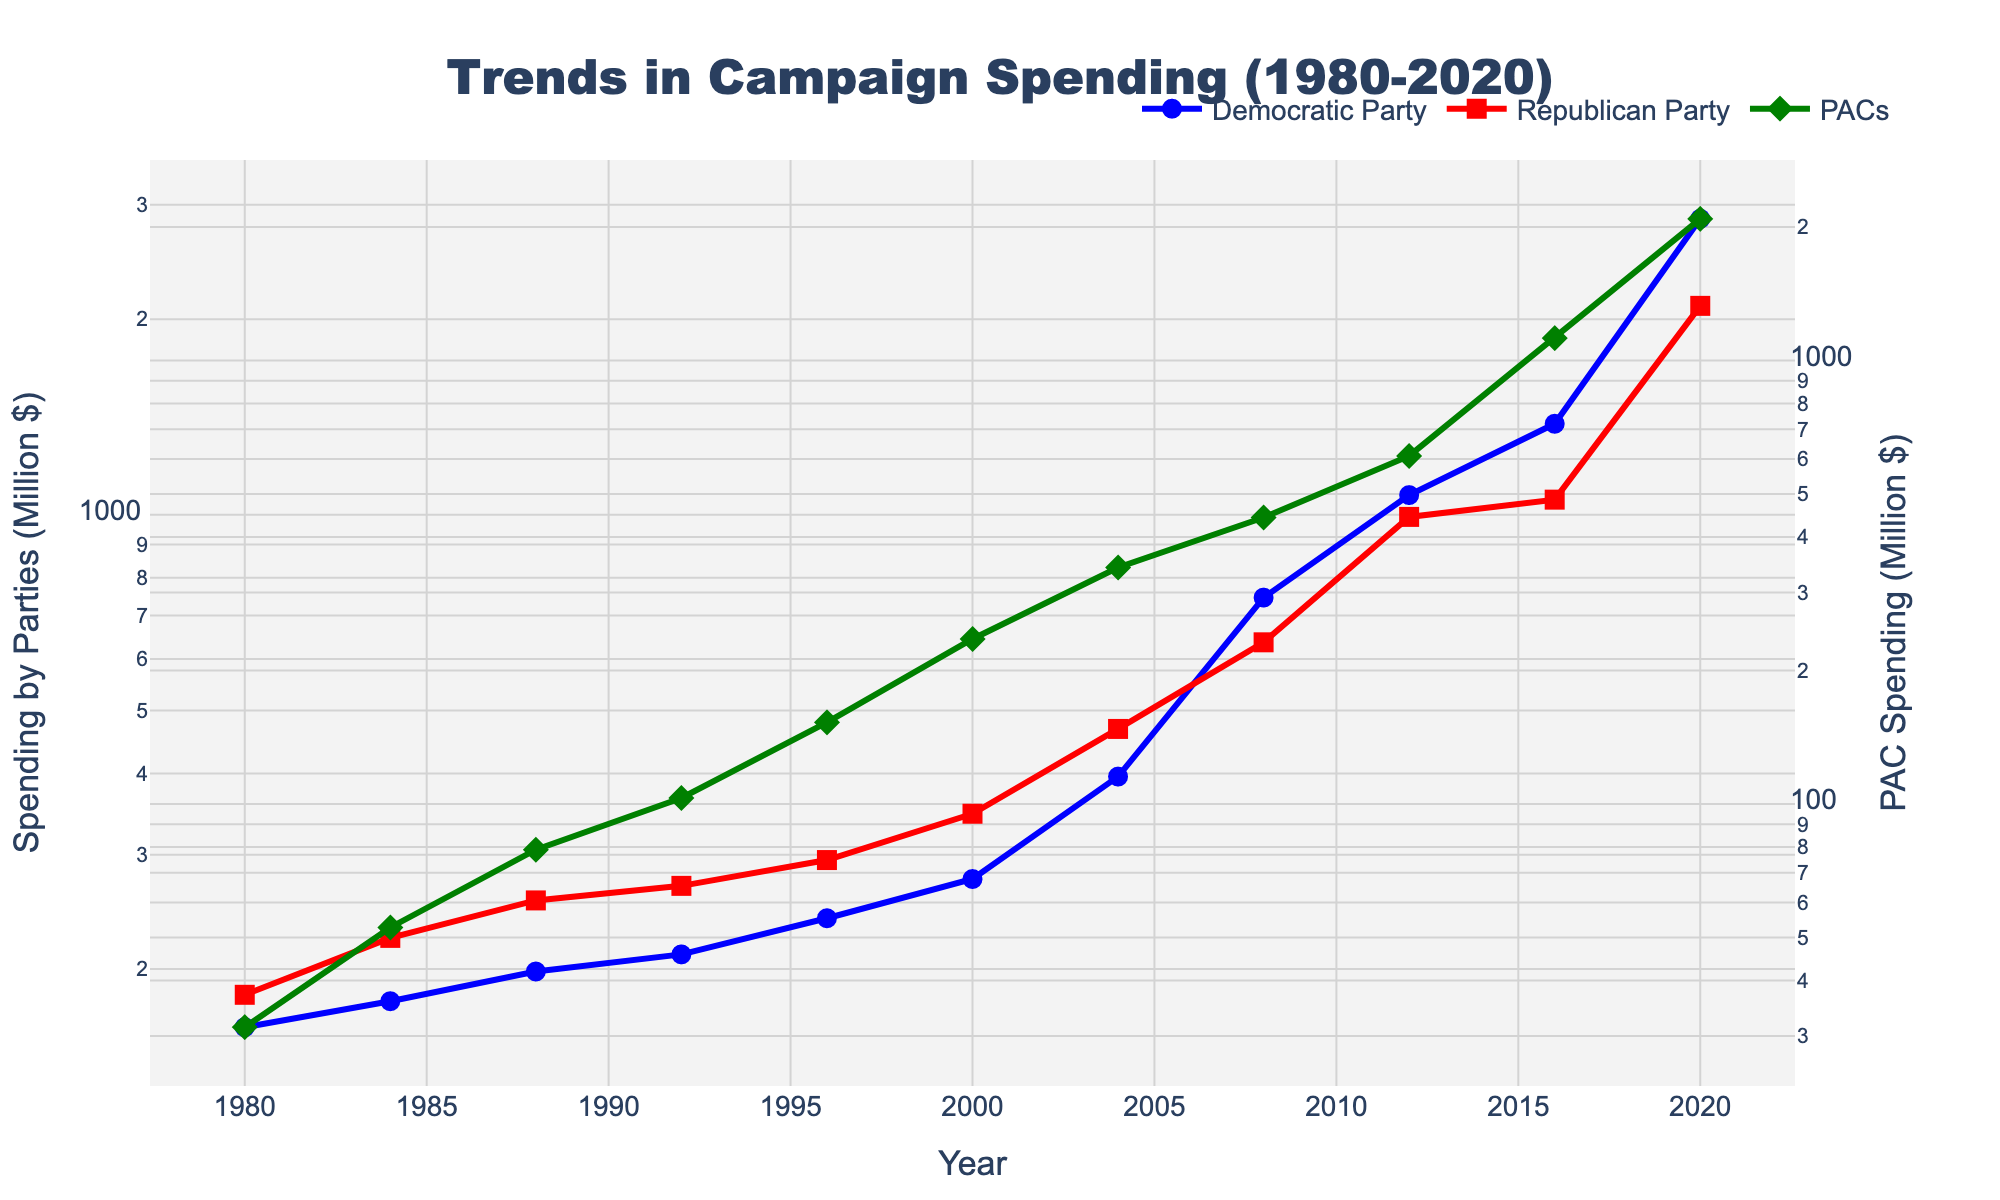What was the spending by the Democratic Party in the year 2000? Locate the point on the blue line corresponding to the year 2000. The y-axis value for the blue line in that year is 275.2 million dollars.
Answer: 275.2 million dollars Which party had higher spending in 1996, the Democratic Party or the Republican Party? Compare the y-values of the blue and red lines in 1996. The y-value for the Democratic Party (blue line) is 239.5 million dollars, and for the Republican Party (red line) it is 294.3 million dollars.
Answer: Republican Party What is the difference in PAC spending between 2016 and 2020? Locate the points on the green line for both 2016 and 2020. The y-values are 1123.8 million dollars in 2016 and 2087.2 million dollars in 2020. Calculate the difference: 2087.2 - 1123.8 = 963.4 million dollars.
Answer: 963.4 million dollars When did the Republican Party's spending surpass 500 million dollars? Follow the red line and find the year when it first crosses the 500 million dollar mark on the y-axis. The value surpasses 500 million dollars in 2008.
Answer: 2008 By how much did Democratic Party's spending increase from 2004 to 2008? Find the y-values for the blue line at 2004 and 2008. The values are 395.6 million dollars in 2004 and 745.8 million dollars in 2008. Calculate the increase: 745.8 - 395.6 = 350.2 million dollars.
Answer: 350.2 million dollars Which has a steeper increase in spending between 2000 and 2016, the Democratic Party or Republican Party? Compare the slope of the blue and red lines between the years 2000 and 2016. The Democratic Party (blue line) rises from 275.2 to 1380.5, and the Republican Party (red line) rises from 346.8 to 1055.2. The steeper increase can be found by the difference: Democratic Party: 1380.5 - 275.2 = 1105.3, Republican Party: 1055.2 - 346.8 = 708.4.
Answer: Democratic Party What is the average spending by PACs between 1980 and 2008? Find the y-values for PAC spending for the years 1980, 1984, 1988, 1992, 1996, 2000, 2004, and 2008. The values are 31.4, 52.7, 78.9, 103.2, 152.8, 235.6, 341.5, and 442.7 respectively. Calculate the sum: 31.4 + 52.7 + 78.9 + 103.2 + 152.8 + 235.6 + 341.5 + 442.7 = 1438.8. Divide by the number of years: 1438.8 / 8 = 179.85 million dollars.
Answer: 179.85 million dollars Which entity had the highest spending in 2012? Compare the y-values of the blue, red, and green lines for the year 2012. The Democratic Party spends 1072.3 million dollars, the Republican Party spends 992.6 million dollars, and PACs spend 609.4 million dollars. The highest value is 1072.3 million dollars by the Democratic Party.
Answer: Democratic Party What trends can be observed in PACs spending from 1980 to 2020? Observe the overall shape and direction of the green line from 1980 to 2020. PACs spending shows a continuous upward trend, with significant increases after 2000, especially peaking at 2087.2 million dollars in 2020.
Answer: Continuous upward trend 